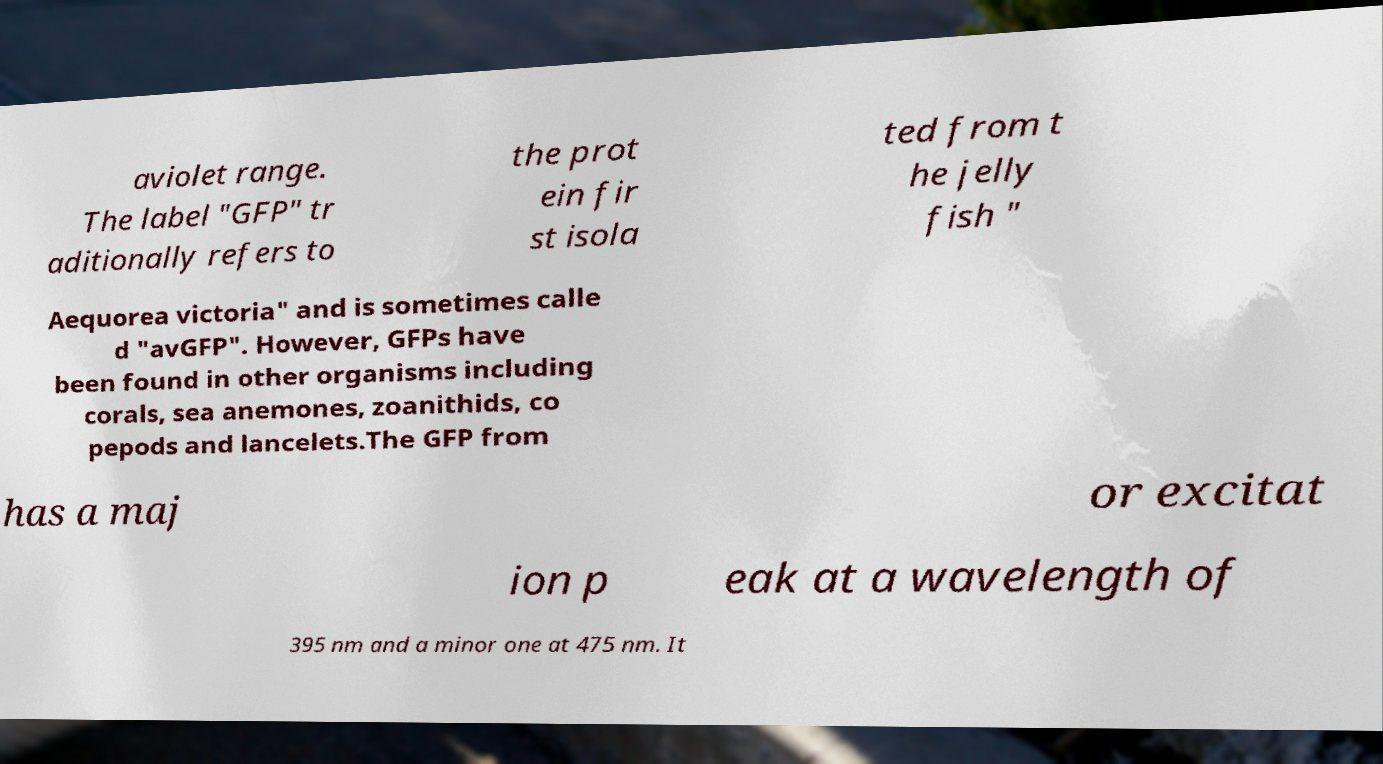For documentation purposes, I need the text within this image transcribed. Could you provide that? aviolet range. The label "GFP" tr aditionally refers to the prot ein fir st isola ted from t he jelly fish " Aequorea victoria" and is sometimes calle d "avGFP". However, GFPs have been found in other organisms including corals, sea anemones, zoanithids, co pepods and lancelets.The GFP from has a maj or excitat ion p eak at a wavelength of 395 nm and a minor one at 475 nm. It 